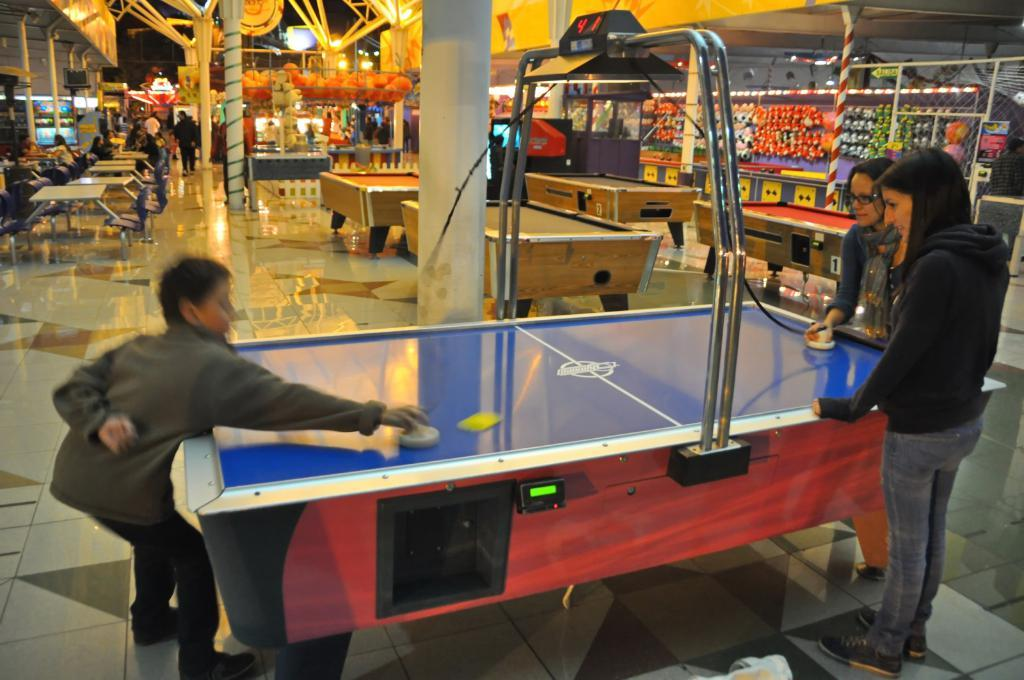What are the people in the image doing? The people in the image are standing in front of a table. What is happening in the background of the image? There are people walking in the background, and stores and pillars are visible. What type of flowers are being planted by the family in the image? There is no family or flowers present in the image; it only shows people standing in front of a table and activities happening in the background. 